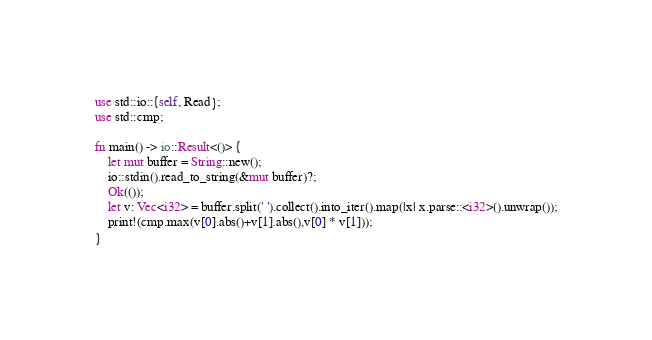<code> <loc_0><loc_0><loc_500><loc_500><_Rust_>use std::io::{self, Read};
use std::cmp;

fn main() -> io::Result<()> {
    let mut buffer = String::new();
    io::stdin().read_to_string(&mut buffer)?;
    Ok(());
    let v: Vec<i32> = buffer.split(' ').collect().into_iter().map(|x| x.parse::<i32>().unwrap());
    print!(cmp.max(v[0].abs()+v[1].abs(),v[0] * v[1]));
}</code> 